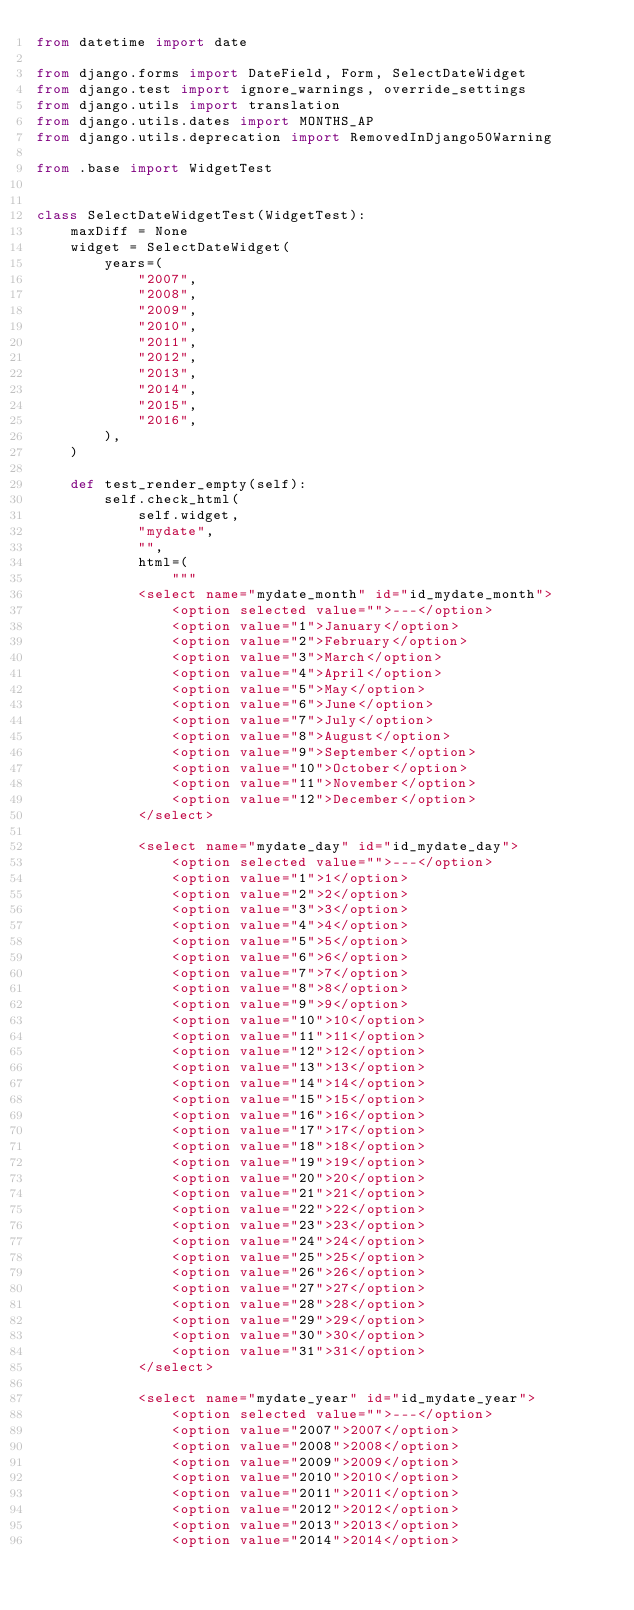Convert code to text. <code><loc_0><loc_0><loc_500><loc_500><_Python_>from datetime import date

from django.forms import DateField, Form, SelectDateWidget
from django.test import ignore_warnings, override_settings
from django.utils import translation
from django.utils.dates import MONTHS_AP
from django.utils.deprecation import RemovedInDjango50Warning

from .base import WidgetTest


class SelectDateWidgetTest(WidgetTest):
    maxDiff = None
    widget = SelectDateWidget(
        years=(
            "2007",
            "2008",
            "2009",
            "2010",
            "2011",
            "2012",
            "2013",
            "2014",
            "2015",
            "2016",
        ),
    )

    def test_render_empty(self):
        self.check_html(
            self.widget,
            "mydate",
            "",
            html=(
                """
            <select name="mydate_month" id="id_mydate_month">
                <option selected value="">---</option>
                <option value="1">January</option>
                <option value="2">February</option>
                <option value="3">March</option>
                <option value="4">April</option>
                <option value="5">May</option>
                <option value="6">June</option>
                <option value="7">July</option>
                <option value="8">August</option>
                <option value="9">September</option>
                <option value="10">October</option>
                <option value="11">November</option>
                <option value="12">December</option>
            </select>

            <select name="mydate_day" id="id_mydate_day">
                <option selected value="">---</option>
                <option value="1">1</option>
                <option value="2">2</option>
                <option value="3">3</option>
                <option value="4">4</option>
                <option value="5">5</option>
                <option value="6">6</option>
                <option value="7">7</option>
                <option value="8">8</option>
                <option value="9">9</option>
                <option value="10">10</option>
                <option value="11">11</option>
                <option value="12">12</option>
                <option value="13">13</option>
                <option value="14">14</option>
                <option value="15">15</option>
                <option value="16">16</option>
                <option value="17">17</option>
                <option value="18">18</option>
                <option value="19">19</option>
                <option value="20">20</option>
                <option value="21">21</option>
                <option value="22">22</option>
                <option value="23">23</option>
                <option value="24">24</option>
                <option value="25">25</option>
                <option value="26">26</option>
                <option value="27">27</option>
                <option value="28">28</option>
                <option value="29">29</option>
                <option value="30">30</option>
                <option value="31">31</option>
            </select>

            <select name="mydate_year" id="id_mydate_year">
                <option selected value="">---</option>
                <option value="2007">2007</option>
                <option value="2008">2008</option>
                <option value="2009">2009</option>
                <option value="2010">2010</option>
                <option value="2011">2011</option>
                <option value="2012">2012</option>
                <option value="2013">2013</option>
                <option value="2014">2014</option></code> 